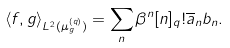Convert formula to latex. <formula><loc_0><loc_0><loc_500><loc_500>\langle f , g \rangle _ { L ^ { 2 } ( \mu _ { g } ^ { ( q ) } ) } = \sum _ { n } \beta ^ { n } [ n ] _ { q } ! \overline { a } _ { n } b _ { n } .</formula> 